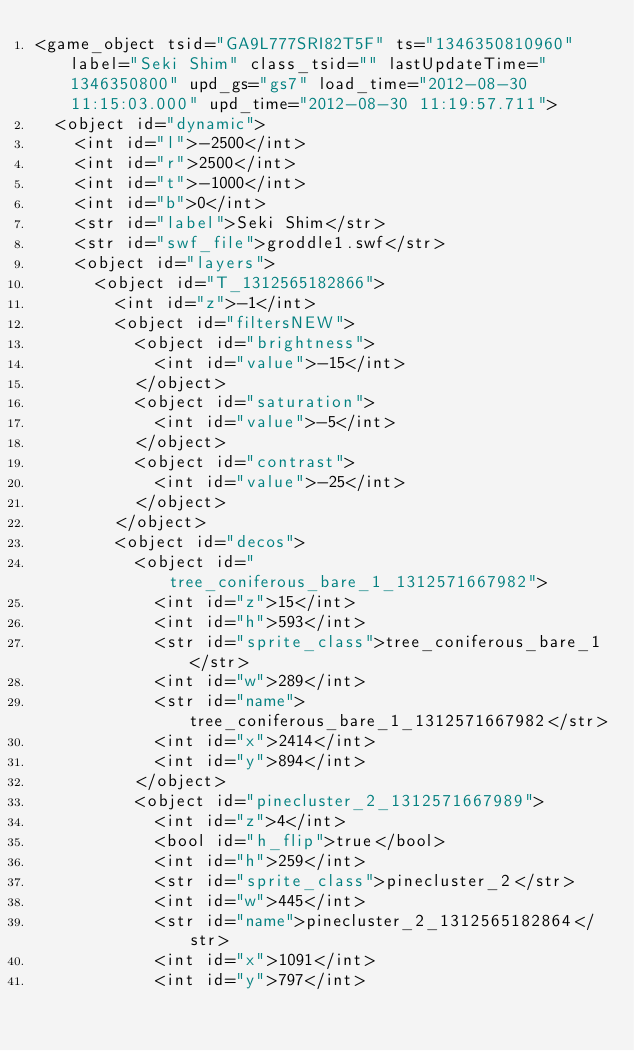Convert code to text. <code><loc_0><loc_0><loc_500><loc_500><_XML_><game_object tsid="GA9L777SRI82T5F" ts="1346350810960" label="Seki Shim" class_tsid="" lastUpdateTime="1346350800" upd_gs="gs7" load_time="2012-08-30 11:15:03.000" upd_time="2012-08-30 11:19:57.711">
	<object id="dynamic">
		<int id="l">-2500</int>
		<int id="r">2500</int>
		<int id="t">-1000</int>
		<int id="b">0</int>
		<str id="label">Seki Shim</str>
		<str id="swf_file">groddle1.swf</str>
		<object id="layers">
			<object id="T_1312565182866">
				<int id="z">-1</int>
				<object id="filtersNEW">
					<object id="brightness">
						<int id="value">-15</int>
					</object>
					<object id="saturation">
						<int id="value">-5</int>
					</object>
					<object id="contrast">
						<int id="value">-25</int>
					</object>
				</object>
				<object id="decos">
					<object id="tree_coniferous_bare_1_1312571667982">
						<int id="z">15</int>
						<int id="h">593</int>
						<str id="sprite_class">tree_coniferous_bare_1</str>
						<int id="w">289</int>
						<str id="name">tree_coniferous_bare_1_1312571667982</str>
						<int id="x">2414</int>
						<int id="y">894</int>
					</object>
					<object id="pinecluster_2_1312571667989">
						<int id="z">4</int>
						<bool id="h_flip">true</bool>
						<int id="h">259</int>
						<str id="sprite_class">pinecluster_2</str>
						<int id="w">445</int>
						<str id="name">pinecluster_2_1312565182864</str>
						<int id="x">1091</int>
						<int id="y">797</int></code> 